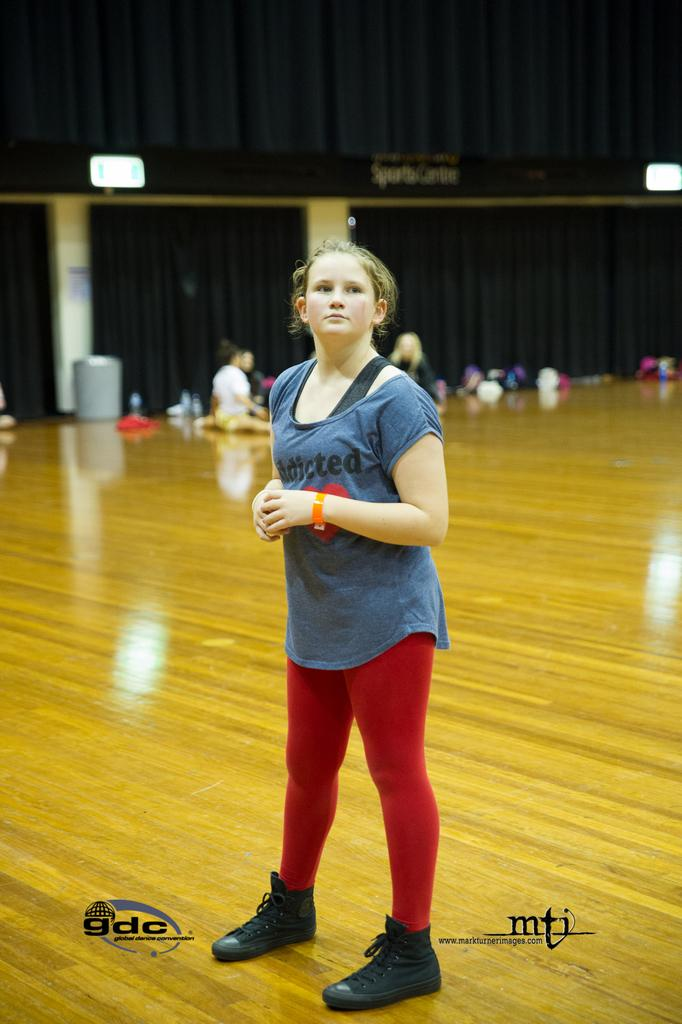What is the primary subject of the image? There is a person standing on the floor in the image. What can be seen in the background of the image? There is a curtain in the background of the image. Are there any other people visible in the image? Yes, there are other persons visible in the image. What is present at the bottom of the image? There is text at the bottom of the image. What type of cake is being shared among the people in the image? There is no cake present in the image; it features a person standing on the floor, a curtain in the background, and other persons visible. 